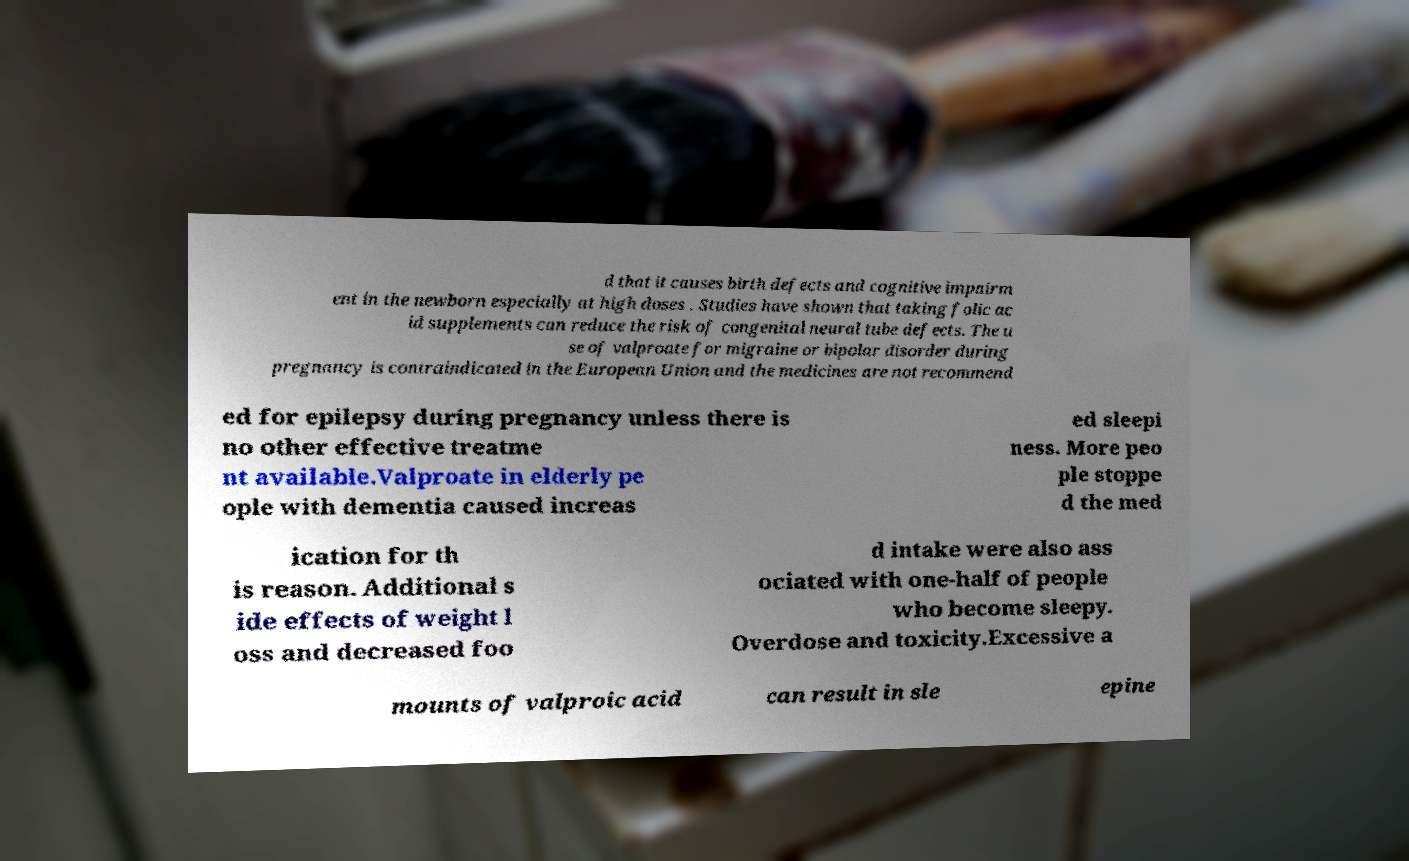Could you assist in decoding the text presented in this image and type it out clearly? d that it causes birth defects and cognitive impairm ent in the newborn especially at high doses . Studies have shown that taking folic ac id supplements can reduce the risk of congenital neural tube defects. The u se of valproate for migraine or bipolar disorder during pregnancy is contraindicated in the European Union and the medicines are not recommend ed for epilepsy during pregnancy unless there is no other effective treatme nt available.Valproate in elderly pe ople with dementia caused increas ed sleepi ness. More peo ple stoppe d the med ication for th is reason. Additional s ide effects of weight l oss and decreased foo d intake were also ass ociated with one-half of people who become sleepy. Overdose and toxicity.Excessive a mounts of valproic acid can result in sle epine 